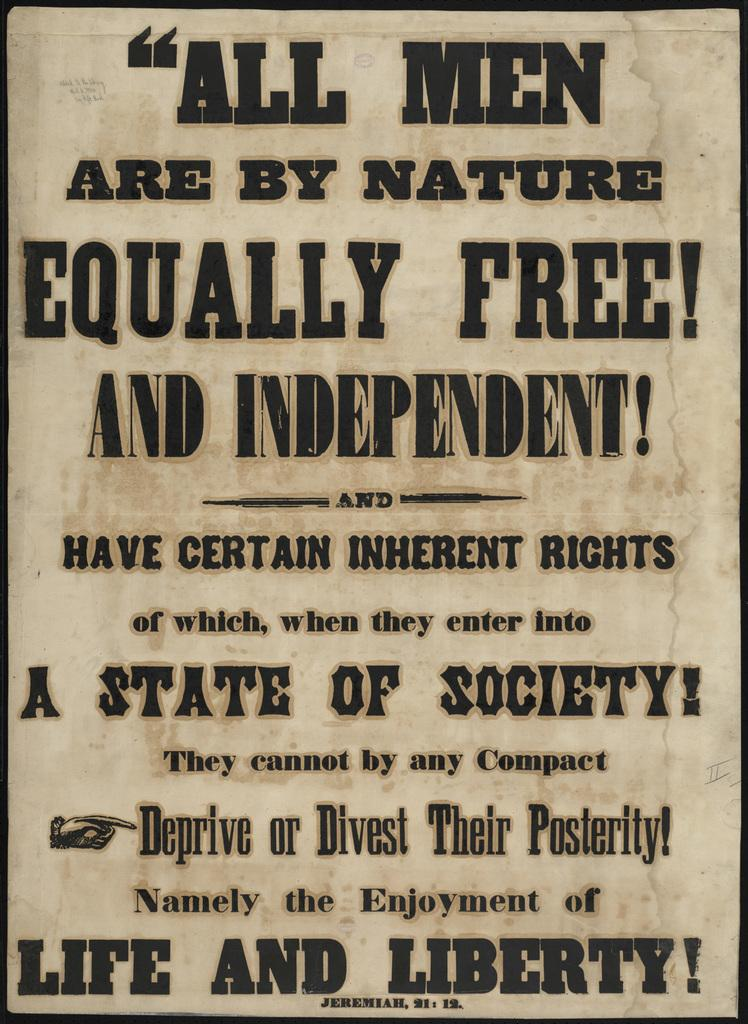Provide a one-sentence caption for the provided image. All men are by nature equally free and independent!. 